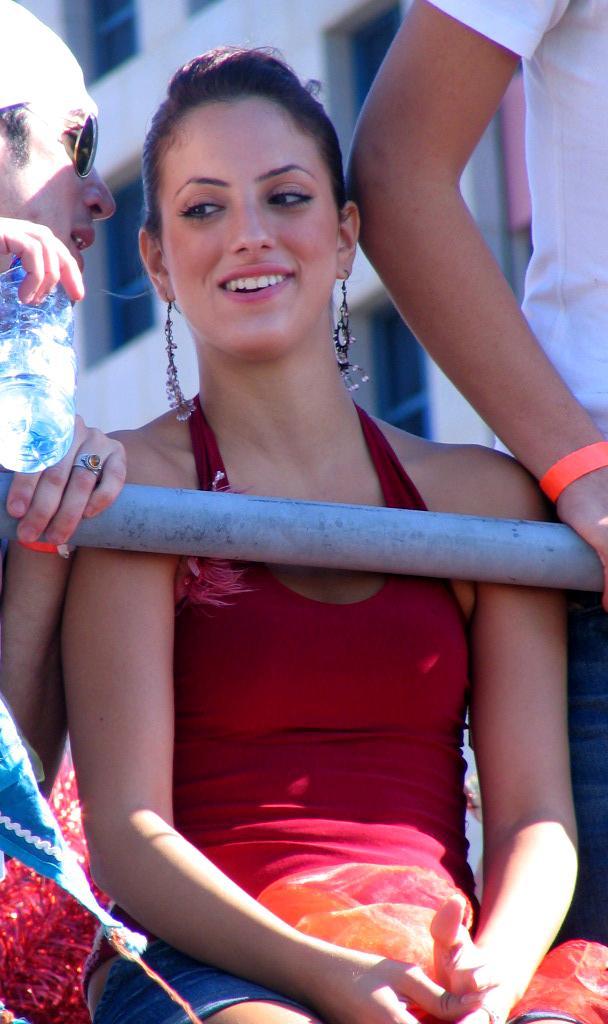Please provide a concise description of this image. In this picture we can see a woman sitting and smiling and beside to her we can see two persons, bottle, rod and in the background we can see a building with windows. 